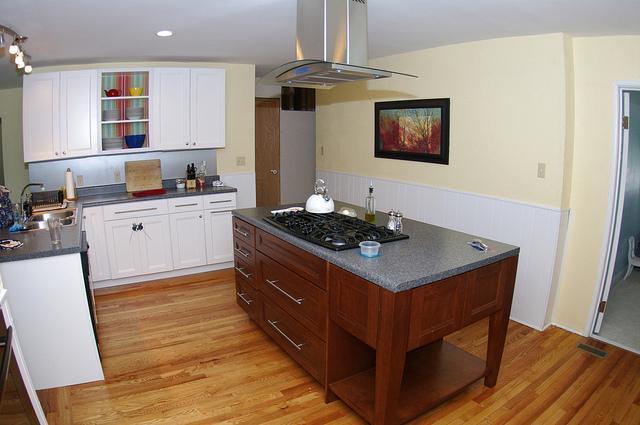How many lights are in the kitchen?
Give a very brief answer. 5. How many people do you see?
Give a very brief answer. 0. 